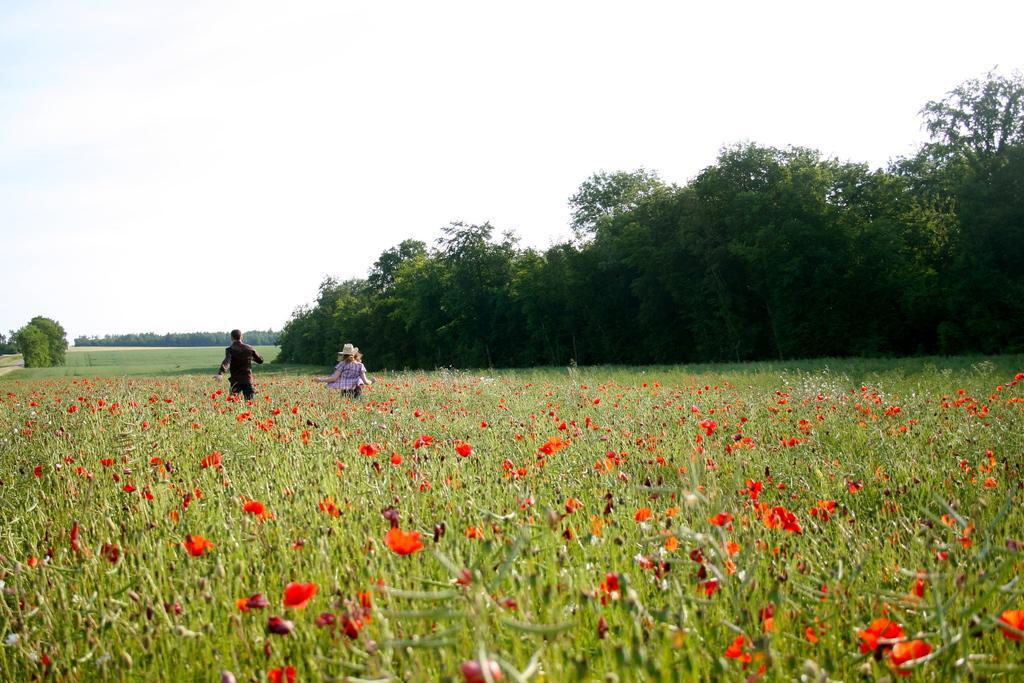How would you summarize this image in a sentence or two? In this image, we can see two persons, plants and flowers. Background we can see trees, grass and sky. 